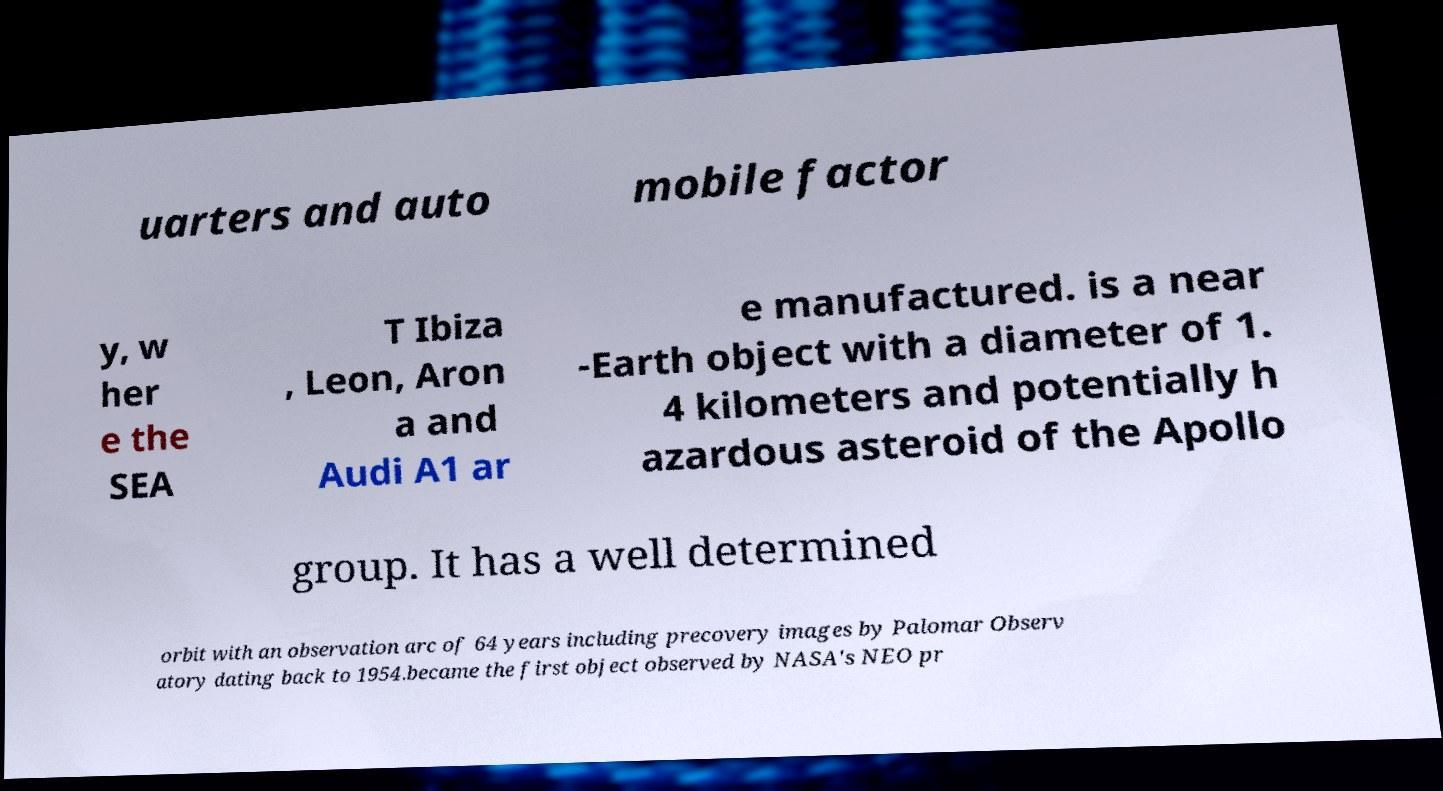What messages or text are displayed in this image? I need them in a readable, typed format. uarters and auto mobile factor y, w her e the SEA T Ibiza , Leon, Aron a and Audi A1 ar e manufactured. is a near -Earth object with a diameter of 1. 4 kilometers and potentially h azardous asteroid of the Apollo group. It has a well determined orbit with an observation arc of 64 years including precovery images by Palomar Observ atory dating back to 1954.became the first object observed by NASA's NEO pr 